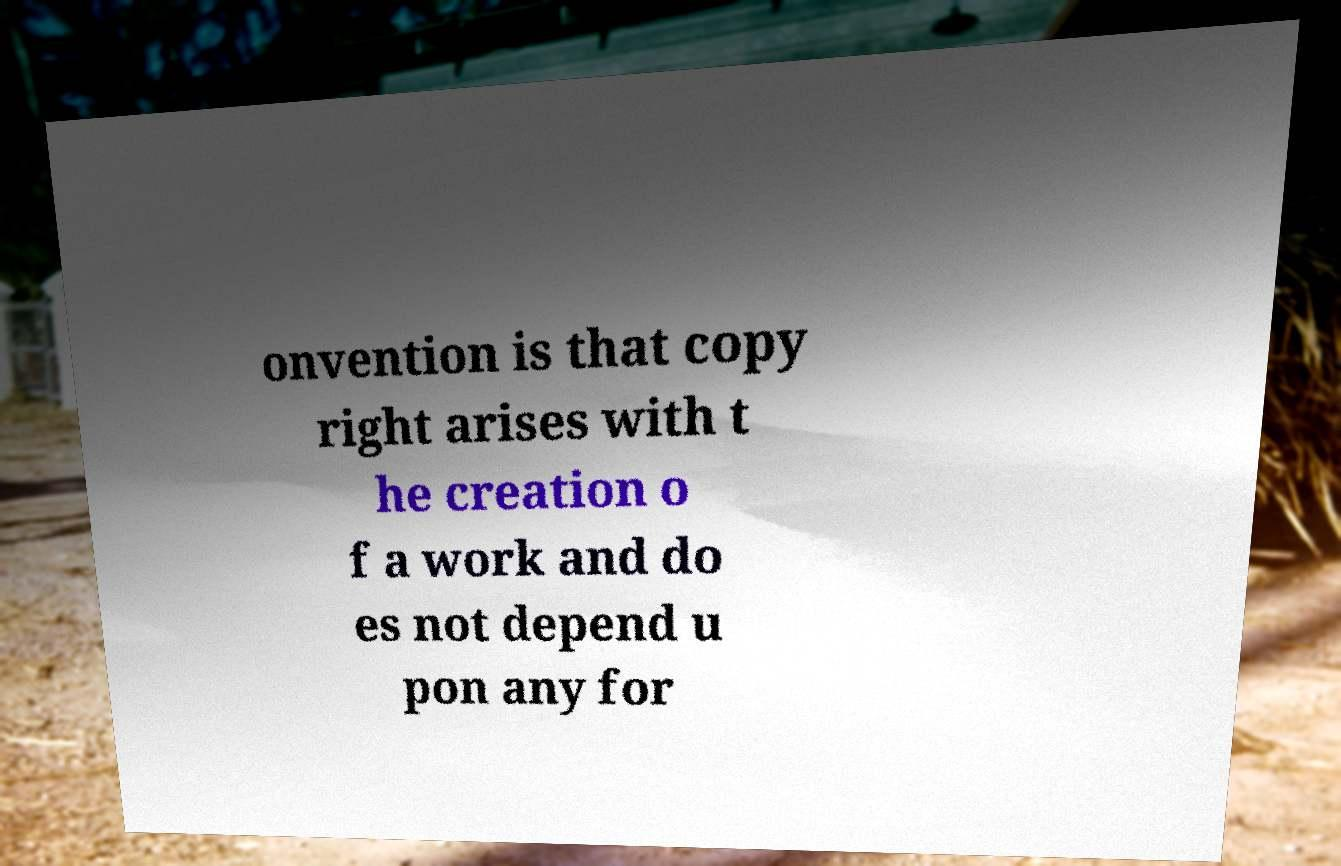There's text embedded in this image that I need extracted. Can you transcribe it verbatim? onvention is that copy right arises with t he creation o f a work and do es not depend u pon any for 